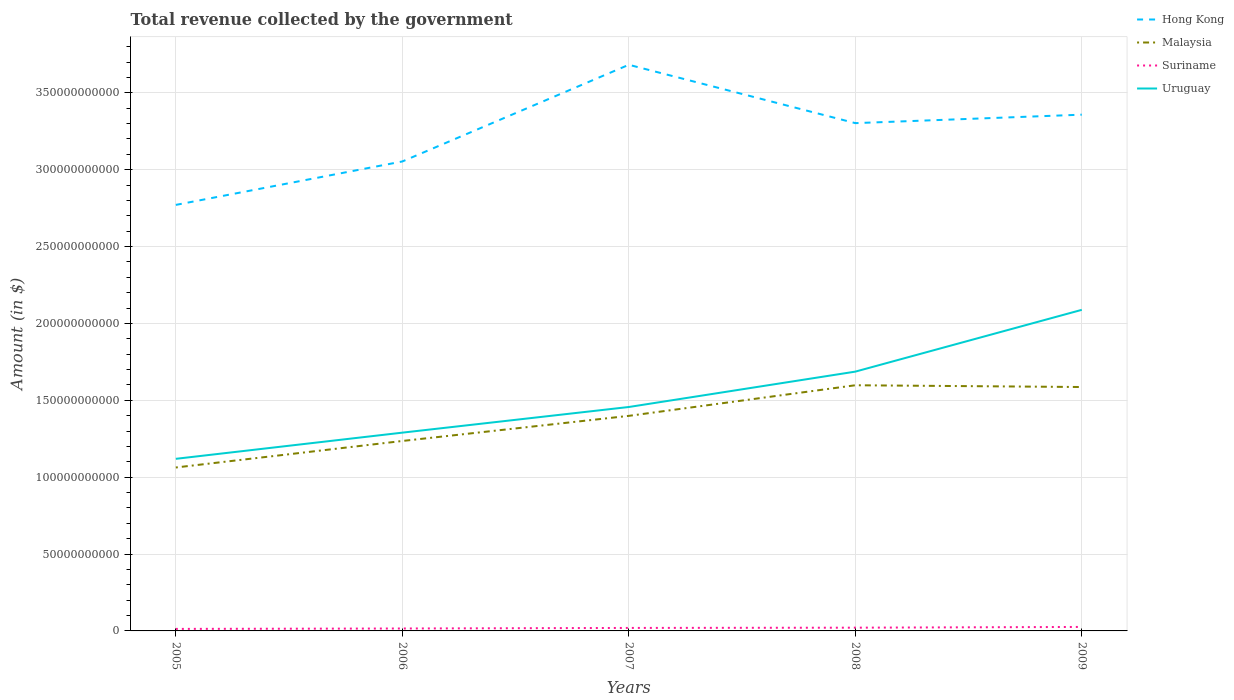How many different coloured lines are there?
Provide a short and direct response. 4. Is the number of lines equal to the number of legend labels?
Give a very brief answer. Yes. Across all years, what is the maximum total revenue collected by the government in Suriname?
Provide a short and direct response. 1.32e+09. What is the total total revenue collected by the government in Hong Kong in the graph?
Your answer should be very brief. -2.49e+1. What is the difference between the highest and the second highest total revenue collected by the government in Suriname?
Provide a short and direct response. 1.28e+09. Is the total revenue collected by the government in Suriname strictly greater than the total revenue collected by the government in Hong Kong over the years?
Your answer should be compact. Yes. What is the difference between two consecutive major ticks on the Y-axis?
Your answer should be very brief. 5.00e+1. Does the graph contain any zero values?
Offer a very short reply. No. Does the graph contain grids?
Provide a succinct answer. Yes. Where does the legend appear in the graph?
Your answer should be very brief. Top right. How are the legend labels stacked?
Your answer should be compact. Vertical. What is the title of the graph?
Keep it short and to the point. Total revenue collected by the government. Does "St. Lucia" appear as one of the legend labels in the graph?
Your response must be concise. No. What is the label or title of the Y-axis?
Your answer should be very brief. Amount (in $). What is the Amount (in $) in Hong Kong in 2005?
Ensure brevity in your answer.  2.77e+11. What is the Amount (in $) of Malaysia in 2005?
Make the answer very short. 1.06e+11. What is the Amount (in $) in Suriname in 2005?
Your answer should be compact. 1.32e+09. What is the Amount (in $) of Uruguay in 2005?
Give a very brief answer. 1.12e+11. What is the Amount (in $) of Hong Kong in 2006?
Give a very brief answer. 3.05e+11. What is the Amount (in $) of Malaysia in 2006?
Ensure brevity in your answer.  1.24e+11. What is the Amount (in $) of Suriname in 2006?
Provide a succinct answer. 1.58e+09. What is the Amount (in $) in Uruguay in 2006?
Keep it short and to the point. 1.29e+11. What is the Amount (in $) of Hong Kong in 2007?
Offer a very short reply. 3.68e+11. What is the Amount (in $) of Malaysia in 2007?
Provide a succinct answer. 1.40e+11. What is the Amount (in $) of Suriname in 2007?
Your answer should be compact. 1.94e+09. What is the Amount (in $) in Uruguay in 2007?
Your response must be concise. 1.46e+11. What is the Amount (in $) in Hong Kong in 2008?
Provide a short and direct response. 3.30e+11. What is the Amount (in $) in Malaysia in 2008?
Provide a short and direct response. 1.60e+11. What is the Amount (in $) of Suriname in 2008?
Give a very brief answer. 2.11e+09. What is the Amount (in $) in Uruguay in 2008?
Offer a terse response. 1.69e+11. What is the Amount (in $) in Hong Kong in 2009?
Provide a succinct answer. 3.36e+11. What is the Amount (in $) of Malaysia in 2009?
Provide a succinct answer. 1.59e+11. What is the Amount (in $) in Suriname in 2009?
Ensure brevity in your answer.  2.59e+09. What is the Amount (in $) in Uruguay in 2009?
Offer a terse response. 2.09e+11. Across all years, what is the maximum Amount (in $) in Hong Kong?
Make the answer very short. 3.68e+11. Across all years, what is the maximum Amount (in $) of Malaysia?
Your response must be concise. 1.60e+11. Across all years, what is the maximum Amount (in $) of Suriname?
Make the answer very short. 2.59e+09. Across all years, what is the maximum Amount (in $) in Uruguay?
Your answer should be compact. 2.09e+11. Across all years, what is the minimum Amount (in $) of Hong Kong?
Your response must be concise. 2.77e+11. Across all years, what is the minimum Amount (in $) of Malaysia?
Offer a very short reply. 1.06e+11. Across all years, what is the minimum Amount (in $) of Suriname?
Provide a succinct answer. 1.32e+09. Across all years, what is the minimum Amount (in $) of Uruguay?
Ensure brevity in your answer.  1.12e+11. What is the total Amount (in $) in Hong Kong in the graph?
Offer a terse response. 1.62e+12. What is the total Amount (in $) in Malaysia in the graph?
Give a very brief answer. 6.88e+11. What is the total Amount (in $) of Suriname in the graph?
Give a very brief answer. 9.54e+09. What is the total Amount (in $) in Uruguay in the graph?
Provide a short and direct response. 7.64e+11. What is the difference between the Amount (in $) of Hong Kong in 2005 and that in 2006?
Your response must be concise. -2.82e+1. What is the difference between the Amount (in $) of Malaysia in 2005 and that in 2006?
Provide a short and direct response. -1.72e+1. What is the difference between the Amount (in $) of Suriname in 2005 and that in 2006?
Ensure brevity in your answer.  -2.65e+08. What is the difference between the Amount (in $) in Uruguay in 2005 and that in 2006?
Your answer should be compact. -1.70e+1. What is the difference between the Amount (in $) in Hong Kong in 2005 and that in 2007?
Your answer should be compact. -9.11e+1. What is the difference between the Amount (in $) in Malaysia in 2005 and that in 2007?
Keep it short and to the point. -3.36e+1. What is the difference between the Amount (in $) of Suriname in 2005 and that in 2007?
Make the answer very short. -6.30e+08. What is the difference between the Amount (in $) in Uruguay in 2005 and that in 2007?
Provide a short and direct response. -3.37e+1. What is the difference between the Amount (in $) in Hong Kong in 2005 and that in 2008?
Give a very brief answer. -5.32e+1. What is the difference between the Amount (in $) of Malaysia in 2005 and that in 2008?
Your answer should be compact. -5.35e+1. What is the difference between the Amount (in $) in Suriname in 2005 and that in 2008?
Your answer should be compact. -7.96e+08. What is the difference between the Amount (in $) in Uruguay in 2005 and that in 2008?
Offer a terse response. -5.67e+1. What is the difference between the Amount (in $) of Hong Kong in 2005 and that in 2009?
Keep it short and to the point. -5.87e+1. What is the difference between the Amount (in $) of Malaysia in 2005 and that in 2009?
Your response must be concise. -5.23e+1. What is the difference between the Amount (in $) of Suriname in 2005 and that in 2009?
Ensure brevity in your answer.  -1.28e+09. What is the difference between the Amount (in $) of Uruguay in 2005 and that in 2009?
Your answer should be very brief. -9.69e+1. What is the difference between the Amount (in $) of Hong Kong in 2006 and that in 2007?
Ensure brevity in your answer.  -6.29e+1. What is the difference between the Amount (in $) of Malaysia in 2006 and that in 2007?
Your answer should be compact. -1.63e+1. What is the difference between the Amount (in $) in Suriname in 2006 and that in 2007?
Offer a very short reply. -3.64e+08. What is the difference between the Amount (in $) of Uruguay in 2006 and that in 2007?
Ensure brevity in your answer.  -1.67e+1. What is the difference between the Amount (in $) of Hong Kong in 2006 and that in 2008?
Ensure brevity in your answer.  -2.49e+1. What is the difference between the Amount (in $) of Malaysia in 2006 and that in 2008?
Offer a very short reply. -3.62e+1. What is the difference between the Amount (in $) of Suriname in 2006 and that in 2008?
Make the answer very short. -5.31e+08. What is the difference between the Amount (in $) in Uruguay in 2006 and that in 2008?
Your response must be concise. -3.97e+1. What is the difference between the Amount (in $) of Hong Kong in 2006 and that in 2009?
Your response must be concise. -3.04e+1. What is the difference between the Amount (in $) of Malaysia in 2006 and that in 2009?
Your response must be concise. -3.51e+1. What is the difference between the Amount (in $) in Suriname in 2006 and that in 2009?
Your answer should be compact. -1.01e+09. What is the difference between the Amount (in $) of Uruguay in 2006 and that in 2009?
Make the answer very short. -7.99e+1. What is the difference between the Amount (in $) in Hong Kong in 2007 and that in 2008?
Ensure brevity in your answer.  3.80e+1. What is the difference between the Amount (in $) of Malaysia in 2007 and that in 2008?
Make the answer very short. -1.99e+1. What is the difference between the Amount (in $) in Suriname in 2007 and that in 2008?
Give a very brief answer. -1.66e+08. What is the difference between the Amount (in $) in Uruguay in 2007 and that in 2008?
Your response must be concise. -2.30e+1. What is the difference between the Amount (in $) in Hong Kong in 2007 and that in 2009?
Offer a terse response. 3.24e+1. What is the difference between the Amount (in $) in Malaysia in 2007 and that in 2009?
Make the answer very short. -1.88e+1. What is the difference between the Amount (in $) of Suriname in 2007 and that in 2009?
Your response must be concise. -6.46e+08. What is the difference between the Amount (in $) in Uruguay in 2007 and that in 2009?
Offer a terse response. -6.32e+1. What is the difference between the Amount (in $) of Hong Kong in 2008 and that in 2009?
Your answer should be compact. -5.50e+09. What is the difference between the Amount (in $) of Malaysia in 2008 and that in 2009?
Make the answer very short. 1.15e+09. What is the difference between the Amount (in $) in Suriname in 2008 and that in 2009?
Ensure brevity in your answer.  -4.79e+08. What is the difference between the Amount (in $) of Uruguay in 2008 and that in 2009?
Provide a short and direct response. -4.02e+1. What is the difference between the Amount (in $) of Hong Kong in 2005 and the Amount (in $) of Malaysia in 2006?
Your response must be concise. 1.54e+11. What is the difference between the Amount (in $) in Hong Kong in 2005 and the Amount (in $) in Suriname in 2006?
Provide a succinct answer. 2.76e+11. What is the difference between the Amount (in $) of Hong Kong in 2005 and the Amount (in $) of Uruguay in 2006?
Ensure brevity in your answer.  1.48e+11. What is the difference between the Amount (in $) of Malaysia in 2005 and the Amount (in $) of Suriname in 2006?
Your response must be concise. 1.05e+11. What is the difference between the Amount (in $) of Malaysia in 2005 and the Amount (in $) of Uruguay in 2006?
Provide a succinct answer. -2.27e+1. What is the difference between the Amount (in $) of Suriname in 2005 and the Amount (in $) of Uruguay in 2006?
Your answer should be compact. -1.28e+11. What is the difference between the Amount (in $) in Hong Kong in 2005 and the Amount (in $) in Malaysia in 2007?
Provide a short and direct response. 1.37e+11. What is the difference between the Amount (in $) in Hong Kong in 2005 and the Amount (in $) in Suriname in 2007?
Ensure brevity in your answer.  2.75e+11. What is the difference between the Amount (in $) in Hong Kong in 2005 and the Amount (in $) in Uruguay in 2007?
Offer a very short reply. 1.31e+11. What is the difference between the Amount (in $) in Malaysia in 2005 and the Amount (in $) in Suriname in 2007?
Offer a terse response. 1.04e+11. What is the difference between the Amount (in $) of Malaysia in 2005 and the Amount (in $) of Uruguay in 2007?
Your response must be concise. -3.93e+1. What is the difference between the Amount (in $) in Suriname in 2005 and the Amount (in $) in Uruguay in 2007?
Your response must be concise. -1.44e+11. What is the difference between the Amount (in $) in Hong Kong in 2005 and the Amount (in $) in Malaysia in 2008?
Your response must be concise. 1.17e+11. What is the difference between the Amount (in $) of Hong Kong in 2005 and the Amount (in $) of Suriname in 2008?
Ensure brevity in your answer.  2.75e+11. What is the difference between the Amount (in $) in Hong Kong in 2005 and the Amount (in $) in Uruguay in 2008?
Your answer should be compact. 1.08e+11. What is the difference between the Amount (in $) in Malaysia in 2005 and the Amount (in $) in Suriname in 2008?
Offer a terse response. 1.04e+11. What is the difference between the Amount (in $) of Malaysia in 2005 and the Amount (in $) of Uruguay in 2008?
Ensure brevity in your answer.  -6.23e+1. What is the difference between the Amount (in $) in Suriname in 2005 and the Amount (in $) in Uruguay in 2008?
Keep it short and to the point. -1.67e+11. What is the difference between the Amount (in $) in Hong Kong in 2005 and the Amount (in $) in Malaysia in 2009?
Offer a very short reply. 1.18e+11. What is the difference between the Amount (in $) in Hong Kong in 2005 and the Amount (in $) in Suriname in 2009?
Keep it short and to the point. 2.75e+11. What is the difference between the Amount (in $) in Hong Kong in 2005 and the Amount (in $) in Uruguay in 2009?
Provide a succinct answer. 6.83e+1. What is the difference between the Amount (in $) of Malaysia in 2005 and the Amount (in $) of Suriname in 2009?
Give a very brief answer. 1.04e+11. What is the difference between the Amount (in $) of Malaysia in 2005 and the Amount (in $) of Uruguay in 2009?
Offer a very short reply. -1.03e+11. What is the difference between the Amount (in $) of Suriname in 2005 and the Amount (in $) of Uruguay in 2009?
Your response must be concise. -2.08e+11. What is the difference between the Amount (in $) in Hong Kong in 2006 and the Amount (in $) in Malaysia in 2007?
Make the answer very short. 1.65e+11. What is the difference between the Amount (in $) of Hong Kong in 2006 and the Amount (in $) of Suriname in 2007?
Ensure brevity in your answer.  3.03e+11. What is the difference between the Amount (in $) in Hong Kong in 2006 and the Amount (in $) in Uruguay in 2007?
Your response must be concise. 1.60e+11. What is the difference between the Amount (in $) in Malaysia in 2006 and the Amount (in $) in Suriname in 2007?
Provide a succinct answer. 1.22e+11. What is the difference between the Amount (in $) in Malaysia in 2006 and the Amount (in $) in Uruguay in 2007?
Your answer should be very brief. -2.21e+1. What is the difference between the Amount (in $) of Suriname in 2006 and the Amount (in $) of Uruguay in 2007?
Ensure brevity in your answer.  -1.44e+11. What is the difference between the Amount (in $) of Hong Kong in 2006 and the Amount (in $) of Malaysia in 2008?
Your answer should be very brief. 1.46e+11. What is the difference between the Amount (in $) of Hong Kong in 2006 and the Amount (in $) of Suriname in 2008?
Provide a short and direct response. 3.03e+11. What is the difference between the Amount (in $) of Hong Kong in 2006 and the Amount (in $) of Uruguay in 2008?
Your answer should be compact. 1.37e+11. What is the difference between the Amount (in $) of Malaysia in 2006 and the Amount (in $) of Suriname in 2008?
Offer a very short reply. 1.21e+11. What is the difference between the Amount (in $) of Malaysia in 2006 and the Amount (in $) of Uruguay in 2008?
Your answer should be very brief. -4.51e+1. What is the difference between the Amount (in $) in Suriname in 2006 and the Amount (in $) in Uruguay in 2008?
Make the answer very short. -1.67e+11. What is the difference between the Amount (in $) of Hong Kong in 2006 and the Amount (in $) of Malaysia in 2009?
Offer a very short reply. 1.47e+11. What is the difference between the Amount (in $) of Hong Kong in 2006 and the Amount (in $) of Suriname in 2009?
Provide a short and direct response. 3.03e+11. What is the difference between the Amount (in $) in Hong Kong in 2006 and the Amount (in $) in Uruguay in 2009?
Your response must be concise. 9.65e+1. What is the difference between the Amount (in $) of Malaysia in 2006 and the Amount (in $) of Suriname in 2009?
Offer a very short reply. 1.21e+11. What is the difference between the Amount (in $) of Malaysia in 2006 and the Amount (in $) of Uruguay in 2009?
Give a very brief answer. -8.53e+1. What is the difference between the Amount (in $) in Suriname in 2006 and the Amount (in $) in Uruguay in 2009?
Ensure brevity in your answer.  -2.07e+11. What is the difference between the Amount (in $) of Hong Kong in 2007 and the Amount (in $) of Malaysia in 2008?
Make the answer very short. 2.08e+11. What is the difference between the Amount (in $) of Hong Kong in 2007 and the Amount (in $) of Suriname in 2008?
Ensure brevity in your answer.  3.66e+11. What is the difference between the Amount (in $) of Hong Kong in 2007 and the Amount (in $) of Uruguay in 2008?
Offer a very short reply. 2.00e+11. What is the difference between the Amount (in $) in Malaysia in 2007 and the Amount (in $) in Suriname in 2008?
Your answer should be compact. 1.38e+11. What is the difference between the Amount (in $) of Malaysia in 2007 and the Amount (in $) of Uruguay in 2008?
Ensure brevity in your answer.  -2.88e+1. What is the difference between the Amount (in $) of Suriname in 2007 and the Amount (in $) of Uruguay in 2008?
Your response must be concise. -1.67e+11. What is the difference between the Amount (in $) in Hong Kong in 2007 and the Amount (in $) in Malaysia in 2009?
Your response must be concise. 2.10e+11. What is the difference between the Amount (in $) of Hong Kong in 2007 and the Amount (in $) of Suriname in 2009?
Ensure brevity in your answer.  3.66e+11. What is the difference between the Amount (in $) of Hong Kong in 2007 and the Amount (in $) of Uruguay in 2009?
Offer a terse response. 1.59e+11. What is the difference between the Amount (in $) of Malaysia in 2007 and the Amount (in $) of Suriname in 2009?
Provide a short and direct response. 1.37e+11. What is the difference between the Amount (in $) in Malaysia in 2007 and the Amount (in $) in Uruguay in 2009?
Keep it short and to the point. -6.90e+1. What is the difference between the Amount (in $) in Suriname in 2007 and the Amount (in $) in Uruguay in 2009?
Your answer should be compact. -2.07e+11. What is the difference between the Amount (in $) of Hong Kong in 2008 and the Amount (in $) of Malaysia in 2009?
Provide a short and direct response. 1.72e+11. What is the difference between the Amount (in $) in Hong Kong in 2008 and the Amount (in $) in Suriname in 2009?
Offer a terse response. 3.28e+11. What is the difference between the Amount (in $) in Hong Kong in 2008 and the Amount (in $) in Uruguay in 2009?
Your answer should be compact. 1.21e+11. What is the difference between the Amount (in $) in Malaysia in 2008 and the Amount (in $) in Suriname in 2009?
Provide a succinct answer. 1.57e+11. What is the difference between the Amount (in $) in Malaysia in 2008 and the Amount (in $) in Uruguay in 2009?
Offer a terse response. -4.90e+1. What is the difference between the Amount (in $) in Suriname in 2008 and the Amount (in $) in Uruguay in 2009?
Ensure brevity in your answer.  -2.07e+11. What is the average Amount (in $) of Hong Kong per year?
Ensure brevity in your answer.  3.23e+11. What is the average Amount (in $) in Malaysia per year?
Give a very brief answer. 1.38e+11. What is the average Amount (in $) in Suriname per year?
Offer a very short reply. 1.91e+09. What is the average Amount (in $) in Uruguay per year?
Give a very brief answer. 1.53e+11. In the year 2005, what is the difference between the Amount (in $) in Hong Kong and Amount (in $) in Malaysia?
Your answer should be compact. 1.71e+11. In the year 2005, what is the difference between the Amount (in $) of Hong Kong and Amount (in $) of Suriname?
Keep it short and to the point. 2.76e+11. In the year 2005, what is the difference between the Amount (in $) in Hong Kong and Amount (in $) in Uruguay?
Your answer should be compact. 1.65e+11. In the year 2005, what is the difference between the Amount (in $) of Malaysia and Amount (in $) of Suriname?
Your response must be concise. 1.05e+11. In the year 2005, what is the difference between the Amount (in $) in Malaysia and Amount (in $) in Uruguay?
Provide a short and direct response. -5.64e+09. In the year 2005, what is the difference between the Amount (in $) in Suriname and Amount (in $) in Uruguay?
Your answer should be very brief. -1.11e+11. In the year 2006, what is the difference between the Amount (in $) in Hong Kong and Amount (in $) in Malaysia?
Your answer should be very brief. 1.82e+11. In the year 2006, what is the difference between the Amount (in $) of Hong Kong and Amount (in $) of Suriname?
Provide a short and direct response. 3.04e+11. In the year 2006, what is the difference between the Amount (in $) of Hong Kong and Amount (in $) of Uruguay?
Your answer should be very brief. 1.76e+11. In the year 2006, what is the difference between the Amount (in $) of Malaysia and Amount (in $) of Suriname?
Ensure brevity in your answer.  1.22e+11. In the year 2006, what is the difference between the Amount (in $) of Malaysia and Amount (in $) of Uruguay?
Keep it short and to the point. -5.42e+09. In the year 2006, what is the difference between the Amount (in $) of Suriname and Amount (in $) of Uruguay?
Provide a succinct answer. -1.27e+11. In the year 2007, what is the difference between the Amount (in $) in Hong Kong and Amount (in $) in Malaysia?
Offer a very short reply. 2.28e+11. In the year 2007, what is the difference between the Amount (in $) of Hong Kong and Amount (in $) of Suriname?
Provide a short and direct response. 3.66e+11. In the year 2007, what is the difference between the Amount (in $) in Hong Kong and Amount (in $) in Uruguay?
Your response must be concise. 2.23e+11. In the year 2007, what is the difference between the Amount (in $) in Malaysia and Amount (in $) in Suriname?
Make the answer very short. 1.38e+11. In the year 2007, what is the difference between the Amount (in $) of Malaysia and Amount (in $) of Uruguay?
Provide a succinct answer. -5.76e+09. In the year 2007, what is the difference between the Amount (in $) in Suriname and Amount (in $) in Uruguay?
Provide a short and direct response. -1.44e+11. In the year 2008, what is the difference between the Amount (in $) of Hong Kong and Amount (in $) of Malaysia?
Your answer should be very brief. 1.70e+11. In the year 2008, what is the difference between the Amount (in $) in Hong Kong and Amount (in $) in Suriname?
Provide a short and direct response. 3.28e+11. In the year 2008, what is the difference between the Amount (in $) of Hong Kong and Amount (in $) of Uruguay?
Ensure brevity in your answer.  1.62e+11. In the year 2008, what is the difference between the Amount (in $) in Malaysia and Amount (in $) in Suriname?
Give a very brief answer. 1.58e+11. In the year 2008, what is the difference between the Amount (in $) in Malaysia and Amount (in $) in Uruguay?
Offer a terse response. -8.86e+09. In the year 2008, what is the difference between the Amount (in $) of Suriname and Amount (in $) of Uruguay?
Make the answer very short. -1.67e+11. In the year 2009, what is the difference between the Amount (in $) of Hong Kong and Amount (in $) of Malaysia?
Offer a very short reply. 1.77e+11. In the year 2009, what is the difference between the Amount (in $) in Hong Kong and Amount (in $) in Suriname?
Your answer should be compact. 3.33e+11. In the year 2009, what is the difference between the Amount (in $) in Hong Kong and Amount (in $) in Uruguay?
Your answer should be compact. 1.27e+11. In the year 2009, what is the difference between the Amount (in $) of Malaysia and Amount (in $) of Suriname?
Ensure brevity in your answer.  1.56e+11. In the year 2009, what is the difference between the Amount (in $) in Malaysia and Amount (in $) in Uruguay?
Provide a short and direct response. -5.02e+1. In the year 2009, what is the difference between the Amount (in $) of Suriname and Amount (in $) of Uruguay?
Your response must be concise. -2.06e+11. What is the ratio of the Amount (in $) of Hong Kong in 2005 to that in 2006?
Your answer should be very brief. 0.91. What is the ratio of the Amount (in $) of Malaysia in 2005 to that in 2006?
Make the answer very short. 0.86. What is the ratio of the Amount (in $) in Suriname in 2005 to that in 2006?
Your answer should be very brief. 0.83. What is the ratio of the Amount (in $) in Uruguay in 2005 to that in 2006?
Offer a very short reply. 0.87. What is the ratio of the Amount (in $) of Hong Kong in 2005 to that in 2007?
Keep it short and to the point. 0.75. What is the ratio of the Amount (in $) in Malaysia in 2005 to that in 2007?
Keep it short and to the point. 0.76. What is the ratio of the Amount (in $) in Suriname in 2005 to that in 2007?
Provide a succinct answer. 0.68. What is the ratio of the Amount (in $) of Uruguay in 2005 to that in 2007?
Your response must be concise. 0.77. What is the ratio of the Amount (in $) in Hong Kong in 2005 to that in 2008?
Ensure brevity in your answer.  0.84. What is the ratio of the Amount (in $) in Malaysia in 2005 to that in 2008?
Offer a very short reply. 0.67. What is the ratio of the Amount (in $) of Suriname in 2005 to that in 2008?
Provide a succinct answer. 0.62. What is the ratio of the Amount (in $) in Uruguay in 2005 to that in 2008?
Provide a short and direct response. 0.66. What is the ratio of the Amount (in $) in Hong Kong in 2005 to that in 2009?
Ensure brevity in your answer.  0.83. What is the ratio of the Amount (in $) in Malaysia in 2005 to that in 2009?
Keep it short and to the point. 0.67. What is the ratio of the Amount (in $) of Suriname in 2005 to that in 2009?
Your answer should be compact. 0.51. What is the ratio of the Amount (in $) in Uruguay in 2005 to that in 2009?
Your answer should be compact. 0.54. What is the ratio of the Amount (in $) in Hong Kong in 2006 to that in 2007?
Keep it short and to the point. 0.83. What is the ratio of the Amount (in $) of Malaysia in 2006 to that in 2007?
Provide a short and direct response. 0.88. What is the ratio of the Amount (in $) of Suriname in 2006 to that in 2007?
Provide a short and direct response. 0.81. What is the ratio of the Amount (in $) in Uruguay in 2006 to that in 2007?
Provide a short and direct response. 0.89. What is the ratio of the Amount (in $) of Hong Kong in 2006 to that in 2008?
Ensure brevity in your answer.  0.92. What is the ratio of the Amount (in $) of Malaysia in 2006 to that in 2008?
Your response must be concise. 0.77. What is the ratio of the Amount (in $) of Suriname in 2006 to that in 2008?
Offer a very short reply. 0.75. What is the ratio of the Amount (in $) of Uruguay in 2006 to that in 2008?
Offer a terse response. 0.76. What is the ratio of the Amount (in $) in Hong Kong in 2006 to that in 2009?
Your answer should be compact. 0.91. What is the ratio of the Amount (in $) in Malaysia in 2006 to that in 2009?
Provide a succinct answer. 0.78. What is the ratio of the Amount (in $) of Suriname in 2006 to that in 2009?
Make the answer very short. 0.61. What is the ratio of the Amount (in $) in Uruguay in 2006 to that in 2009?
Your response must be concise. 0.62. What is the ratio of the Amount (in $) in Hong Kong in 2007 to that in 2008?
Give a very brief answer. 1.11. What is the ratio of the Amount (in $) in Malaysia in 2007 to that in 2008?
Keep it short and to the point. 0.88. What is the ratio of the Amount (in $) of Suriname in 2007 to that in 2008?
Provide a succinct answer. 0.92. What is the ratio of the Amount (in $) in Uruguay in 2007 to that in 2008?
Provide a succinct answer. 0.86. What is the ratio of the Amount (in $) in Hong Kong in 2007 to that in 2009?
Offer a terse response. 1.1. What is the ratio of the Amount (in $) in Malaysia in 2007 to that in 2009?
Offer a very short reply. 0.88. What is the ratio of the Amount (in $) of Suriname in 2007 to that in 2009?
Provide a short and direct response. 0.75. What is the ratio of the Amount (in $) of Uruguay in 2007 to that in 2009?
Keep it short and to the point. 0.7. What is the ratio of the Amount (in $) in Hong Kong in 2008 to that in 2009?
Provide a succinct answer. 0.98. What is the ratio of the Amount (in $) of Malaysia in 2008 to that in 2009?
Keep it short and to the point. 1.01. What is the ratio of the Amount (in $) of Suriname in 2008 to that in 2009?
Offer a terse response. 0.81. What is the ratio of the Amount (in $) in Uruguay in 2008 to that in 2009?
Provide a succinct answer. 0.81. What is the difference between the highest and the second highest Amount (in $) of Hong Kong?
Make the answer very short. 3.24e+1. What is the difference between the highest and the second highest Amount (in $) of Malaysia?
Offer a very short reply. 1.15e+09. What is the difference between the highest and the second highest Amount (in $) in Suriname?
Your response must be concise. 4.79e+08. What is the difference between the highest and the second highest Amount (in $) of Uruguay?
Offer a very short reply. 4.02e+1. What is the difference between the highest and the lowest Amount (in $) in Hong Kong?
Offer a terse response. 9.11e+1. What is the difference between the highest and the lowest Amount (in $) of Malaysia?
Give a very brief answer. 5.35e+1. What is the difference between the highest and the lowest Amount (in $) in Suriname?
Offer a terse response. 1.28e+09. What is the difference between the highest and the lowest Amount (in $) in Uruguay?
Offer a terse response. 9.69e+1. 